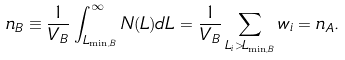Convert formula to latex. <formula><loc_0><loc_0><loc_500><loc_500>n _ { B } \equiv \frac { 1 } { V _ { B } } \int _ { L _ { \min , B } } ^ { \infty } N ( L ) d L = \frac { 1 } { V _ { B } } \sum _ { L _ { i } > L _ { \min , B } } w _ { i } = n _ { A } .</formula> 